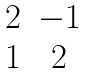<formula> <loc_0><loc_0><loc_500><loc_500>\begin{matrix} 2 & - 1 \\ 1 & 2 \end{matrix}</formula> 